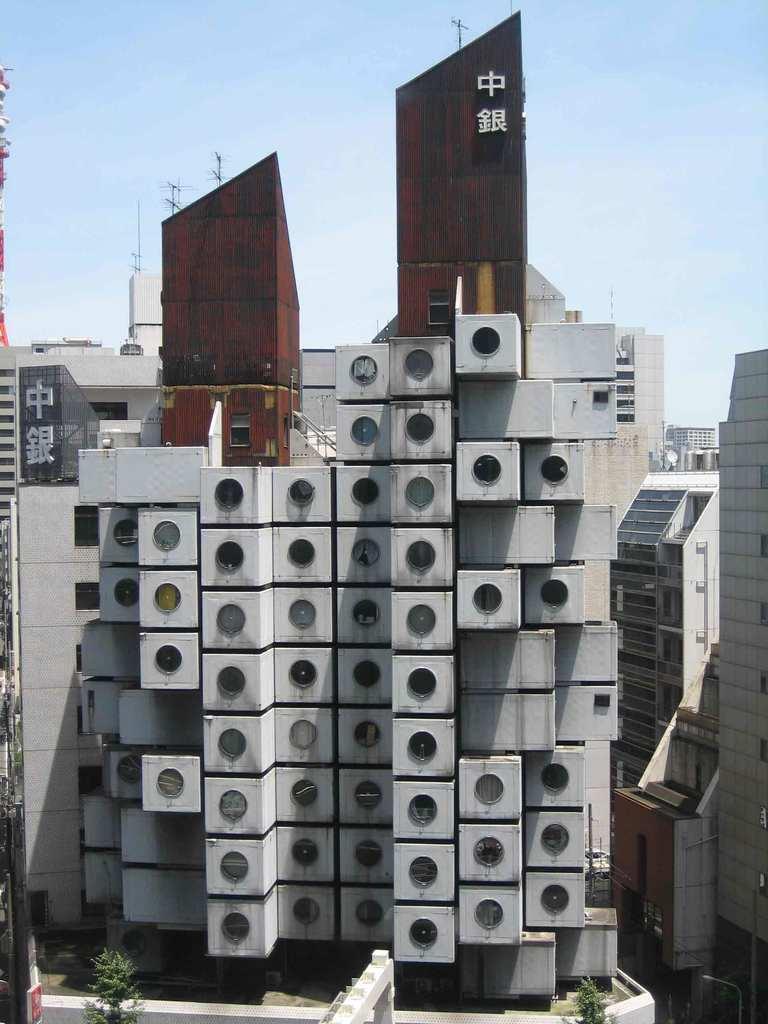The text is in foreign language?
Your response must be concise. Yes. 